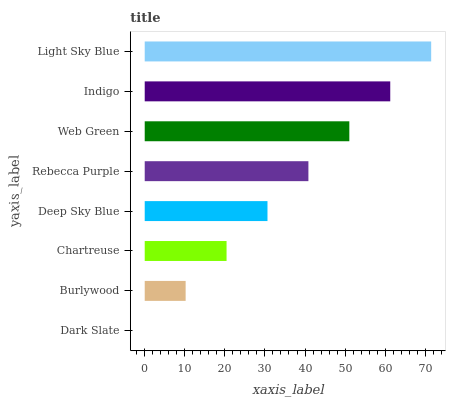Is Dark Slate the minimum?
Answer yes or no. Yes. Is Light Sky Blue the maximum?
Answer yes or no. Yes. Is Burlywood the minimum?
Answer yes or no. No. Is Burlywood the maximum?
Answer yes or no. No. Is Burlywood greater than Dark Slate?
Answer yes or no. Yes. Is Dark Slate less than Burlywood?
Answer yes or no. Yes. Is Dark Slate greater than Burlywood?
Answer yes or no. No. Is Burlywood less than Dark Slate?
Answer yes or no. No. Is Rebecca Purple the high median?
Answer yes or no. Yes. Is Deep Sky Blue the low median?
Answer yes or no. Yes. Is Deep Sky Blue the high median?
Answer yes or no. No. Is Light Sky Blue the low median?
Answer yes or no. No. 